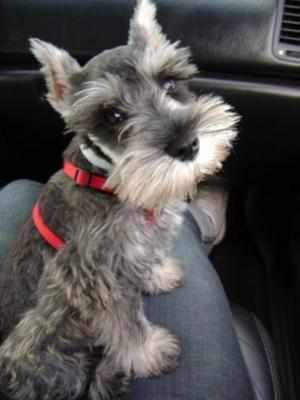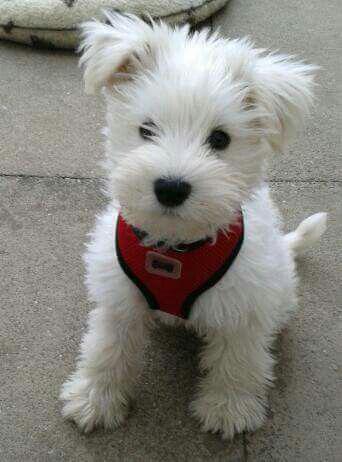The first image is the image on the left, the second image is the image on the right. Assess this claim about the two images: "An image shows an animal with all-white fur.". Correct or not? Answer yes or no. Yes. 